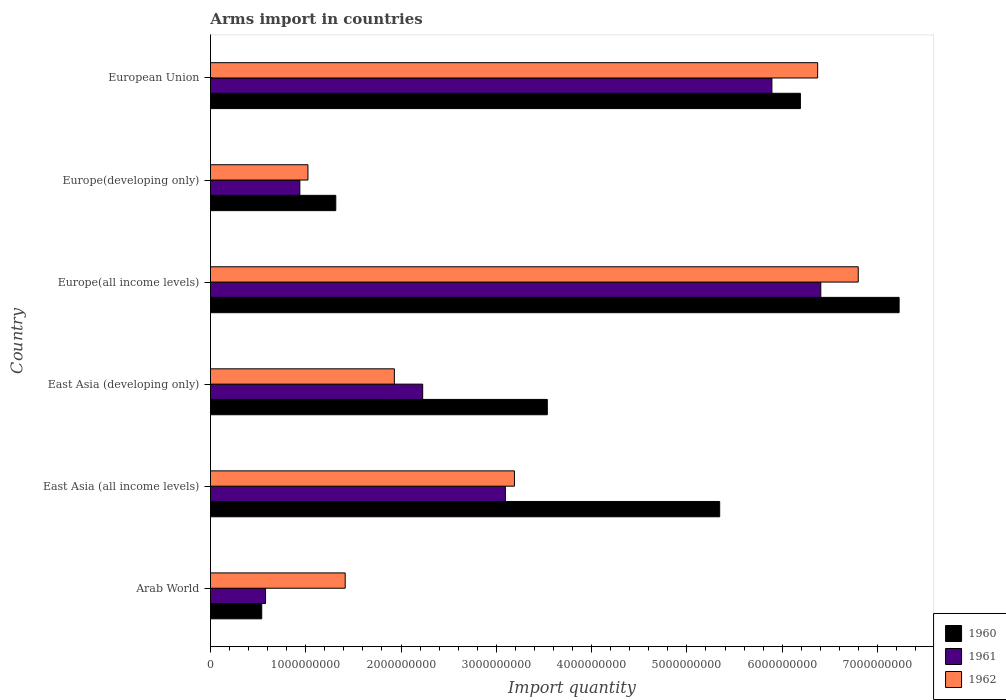How many groups of bars are there?
Provide a succinct answer. 6. Are the number of bars per tick equal to the number of legend labels?
Your answer should be very brief. Yes. Are the number of bars on each tick of the Y-axis equal?
Make the answer very short. Yes. How many bars are there on the 4th tick from the top?
Offer a very short reply. 3. How many bars are there on the 3rd tick from the bottom?
Give a very brief answer. 3. What is the label of the 2nd group of bars from the top?
Your response must be concise. Europe(developing only). What is the total arms import in 1961 in East Asia (all income levels)?
Give a very brief answer. 3.10e+09. Across all countries, what is the maximum total arms import in 1962?
Your answer should be compact. 6.80e+09. Across all countries, what is the minimum total arms import in 1961?
Your answer should be very brief. 5.78e+08. In which country was the total arms import in 1962 maximum?
Provide a short and direct response. Europe(all income levels). In which country was the total arms import in 1960 minimum?
Your answer should be very brief. Arab World. What is the total total arms import in 1962 in the graph?
Your answer should be very brief. 2.07e+1. What is the difference between the total arms import in 1961 in East Asia (developing only) and that in Europe(all income levels)?
Your answer should be very brief. -4.18e+09. What is the difference between the total arms import in 1960 in Europe(developing only) and the total arms import in 1961 in Arab World?
Keep it short and to the point. 7.37e+08. What is the average total arms import in 1962 per country?
Offer a terse response. 3.45e+09. What is the difference between the total arms import in 1960 and total arms import in 1961 in European Union?
Your answer should be very brief. 2.99e+08. What is the ratio of the total arms import in 1961 in Europe(all income levels) to that in Europe(developing only)?
Your answer should be very brief. 6.83. Is the total arms import in 1960 in Arab World less than that in East Asia (developing only)?
Your response must be concise. Yes. Is the difference between the total arms import in 1960 in East Asia (developing only) and European Union greater than the difference between the total arms import in 1961 in East Asia (developing only) and European Union?
Offer a terse response. Yes. What is the difference between the highest and the second highest total arms import in 1961?
Your answer should be compact. 5.13e+08. What is the difference between the highest and the lowest total arms import in 1961?
Offer a terse response. 5.83e+09. What does the 2nd bar from the top in Europe(all income levels) represents?
Provide a short and direct response. 1961. Is it the case that in every country, the sum of the total arms import in 1961 and total arms import in 1960 is greater than the total arms import in 1962?
Offer a terse response. No. How many bars are there?
Ensure brevity in your answer.  18. Are the values on the major ticks of X-axis written in scientific E-notation?
Provide a succinct answer. No. Does the graph contain any zero values?
Your answer should be very brief. No. Does the graph contain grids?
Offer a terse response. No. What is the title of the graph?
Ensure brevity in your answer.  Arms import in countries. Does "1973" appear as one of the legend labels in the graph?
Give a very brief answer. No. What is the label or title of the X-axis?
Your answer should be very brief. Import quantity. What is the Import quantity in 1960 in Arab World?
Your answer should be compact. 5.38e+08. What is the Import quantity in 1961 in Arab World?
Provide a succinct answer. 5.78e+08. What is the Import quantity of 1962 in Arab World?
Provide a short and direct response. 1.41e+09. What is the Import quantity of 1960 in East Asia (all income levels)?
Keep it short and to the point. 5.34e+09. What is the Import quantity in 1961 in East Asia (all income levels)?
Provide a short and direct response. 3.10e+09. What is the Import quantity of 1962 in East Asia (all income levels)?
Provide a succinct answer. 3.19e+09. What is the Import quantity in 1960 in East Asia (developing only)?
Offer a terse response. 3.54e+09. What is the Import quantity in 1961 in East Asia (developing only)?
Keep it short and to the point. 2.23e+09. What is the Import quantity of 1962 in East Asia (developing only)?
Your answer should be compact. 1.93e+09. What is the Import quantity of 1960 in Europe(all income levels)?
Your answer should be compact. 7.23e+09. What is the Import quantity in 1961 in Europe(all income levels)?
Provide a short and direct response. 6.40e+09. What is the Import quantity in 1962 in Europe(all income levels)?
Provide a succinct answer. 6.80e+09. What is the Import quantity in 1960 in Europe(developing only)?
Your answer should be very brief. 1.32e+09. What is the Import quantity in 1961 in Europe(developing only)?
Offer a terse response. 9.38e+08. What is the Import quantity of 1962 in Europe(developing only)?
Your response must be concise. 1.02e+09. What is the Import quantity of 1960 in European Union?
Your response must be concise. 6.19e+09. What is the Import quantity in 1961 in European Union?
Make the answer very short. 5.89e+09. What is the Import quantity of 1962 in European Union?
Your answer should be compact. 6.37e+09. Across all countries, what is the maximum Import quantity in 1960?
Give a very brief answer. 7.23e+09. Across all countries, what is the maximum Import quantity in 1961?
Keep it short and to the point. 6.40e+09. Across all countries, what is the maximum Import quantity in 1962?
Keep it short and to the point. 6.80e+09. Across all countries, what is the minimum Import quantity of 1960?
Provide a succinct answer. 5.38e+08. Across all countries, what is the minimum Import quantity in 1961?
Provide a succinct answer. 5.78e+08. Across all countries, what is the minimum Import quantity of 1962?
Offer a terse response. 1.02e+09. What is the total Import quantity of 1960 in the graph?
Give a very brief answer. 2.42e+1. What is the total Import quantity of 1961 in the graph?
Your answer should be very brief. 1.91e+1. What is the total Import quantity in 1962 in the graph?
Your answer should be very brief. 2.07e+1. What is the difference between the Import quantity in 1960 in Arab World and that in East Asia (all income levels)?
Provide a short and direct response. -4.81e+09. What is the difference between the Import quantity in 1961 in Arab World and that in East Asia (all income levels)?
Offer a terse response. -2.52e+09. What is the difference between the Import quantity of 1962 in Arab World and that in East Asia (all income levels)?
Provide a short and direct response. -1.78e+09. What is the difference between the Import quantity in 1960 in Arab World and that in East Asia (developing only)?
Your answer should be very brief. -3.00e+09. What is the difference between the Import quantity of 1961 in Arab World and that in East Asia (developing only)?
Your answer should be very brief. -1.65e+09. What is the difference between the Import quantity of 1962 in Arab World and that in East Asia (developing only)?
Ensure brevity in your answer.  -5.16e+08. What is the difference between the Import quantity in 1960 in Arab World and that in Europe(all income levels)?
Offer a terse response. -6.69e+09. What is the difference between the Import quantity of 1961 in Arab World and that in Europe(all income levels)?
Your answer should be compact. -5.83e+09. What is the difference between the Import quantity in 1962 in Arab World and that in Europe(all income levels)?
Your answer should be compact. -5.38e+09. What is the difference between the Import quantity of 1960 in Arab World and that in Europe(developing only)?
Provide a short and direct response. -7.77e+08. What is the difference between the Import quantity of 1961 in Arab World and that in Europe(developing only)?
Ensure brevity in your answer.  -3.60e+08. What is the difference between the Import quantity in 1962 in Arab World and that in Europe(developing only)?
Ensure brevity in your answer.  3.91e+08. What is the difference between the Import quantity of 1960 in Arab World and that in European Union?
Your response must be concise. -5.65e+09. What is the difference between the Import quantity of 1961 in Arab World and that in European Union?
Offer a very short reply. -5.31e+09. What is the difference between the Import quantity in 1962 in Arab World and that in European Union?
Your response must be concise. -4.96e+09. What is the difference between the Import quantity of 1960 in East Asia (all income levels) and that in East Asia (developing only)?
Offer a terse response. 1.81e+09. What is the difference between the Import quantity in 1961 in East Asia (all income levels) and that in East Asia (developing only)?
Give a very brief answer. 8.68e+08. What is the difference between the Import quantity in 1962 in East Asia (all income levels) and that in East Asia (developing only)?
Provide a short and direct response. 1.26e+09. What is the difference between the Import quantity in 1960 in East Asia (all income levels) and that in Europe(all income levels)?
Ensure brevity in your answer.  -1.88e+09. What is the difference between the Import quantity in 1961 in East Asia (all income levels) and that in Europe(all income levels)?
Give a very brief answer. -3.31e+09. What is the difference between the Import quantity in 1962 in East Asia (all income levels) and that in Europe(all income levels)?
Provide a short and direct response. -3.61e+09. What is the difference between the Import quantity in 1960 in East Asia (all income levels) and that in Europe(developing only)?
Ensure brevity in your answer.  4.03e+09. What is the difference between the Import quantity in 1961 in East Asia (all income levels) and that in Europe(developing only)?
Offer a very short reply. 2.16e+09. What is the difference between the Import quantity in 1962 in East Asia (all income levels) and that in Europe(developing only)?
Make the answer very short. 2.17e+09. What is the difference between the Import quantity of 1960 in East Asia (all income levels) and that in European Union?
Offer a terse response. -8.47e+08. What is the difference between the Import quantity of 1961 in East Asia (all income levels) and that in European Union?
Your answer should be compact. -2.80e+09. What is the difference between the Import quantity in 1962 in East Asia (all income levels) and that in European Union?
Your response must be concise. -3.18e+09. What is the difference between the Import quantity in 1960 in East Asia (developing only) and that in Europe(all income levels)?
Offer a very short reply. -3.69e+09. What is the difference between the Import quantity in 1961 in East Asia (developing only) and that in Europe(all income levels)?
Provide a short and direct response. -4.18e+09. What is the difference between the Import quantity in 1962 in East Asia (developing only) and that in Europe(all income levels)?
Your response must be concise. -4.87e+09. What is the difference between the Import quantity in 1960 in East Asia (developing only) and that in Europe(developing only)?
Provide a succinct answer. 2.22e+09. What is the difference between the Import quantity in 1961 in East Asia (developing only) and that in Europe(developing only)?
Offer a very short reply. 1.29e+09. What is the difference between the Import quantity of 1962 in East Asia (developing only) and that in Europe(developing only)?
Make the answer very short. 9.07e+08. What is the difference between the Import quantity in 1960 in East Asia (developing only) and that in European Union?
Keep it short and to the point. -2.66e+09. What is the difference between the Import quantity of 1961 in East Asia (developing only) and that in European Union?
Your response must be concise. -3.66e+09. What is the difference between the Import quantity of 1962 in East Asia (developing only) and that in European Union?
Give a very brief answer. -4.44e+09. What is the difference between the Import quantity in 1960 in Europe(all income levels) and that in Europe(developing only)?
Ensure brevity in your answer.  5.91e+09. What is the difference between the Import quantity of 1961 in Europe(all income levels) and that in Europe(developing only)?
Your answer should be very brief. 5.47e+09. What is the difference between the Import quantity of 1962 in Europe(all income levels) and that in Europe(developing only)?
Your answer should be very brief. 5.78e+09. What is the difference between the Import quantity of 1960 in Europe(all income levels) and that in European Union?
Ensure brevity in your answer.  1.04e+09. What is the difference between the Import quantity in 1961 in Europe(all income levels) and that in European Union?
Keep it short and to the point. 5.13e+08. What is the difference between the Import quantity in 1962 in Europe(all income levels) and that in European Union?
Provide a succinct answer. 4.26e+08. What is the difference between the Import quantity in 1960 in Europe(developing only) and that in European Union?
Your response must be concise. -4.88e+09. What is the difference between the Import quantity in 1961 in Europe(developing only) and that in European Union?
Your response must be concise. -4.95e+09. What is the difference between the Import quantity in 1962 in Europe(developing only) and that in European Union?
Ensure brevity in your answer.  -5.35e+09. What is the difference between the Import quantity in 1960 in Arab World and the Import quantity in 1961 in East Asia (all income levels)?
Keep it short and to the point. -2.56e+09. What is the difference between the Import quantity of 1960 in Arab World and the Import quantity of 1962 in East Asia (all income levels)?
Ensure brevity in your answer.  -2.65e+09. What is the difference between the Import quantity in 1961 in Arab World and the Import quantity in 1962 in East Asia (all income levels)?
Offer a very short reply. -2.61e+09. What is the difference between the Import quantity of 1960 in Arab World and the Import quantity of 1961 in East Asia (developing only)?
Your response must be concise. -1.69e+09. What is the difference between the Import quantity in 1960 in Arab World and the Import quantity in 1962 in East Asia (developing only)?
Keep it short and to the point. -1.39e+09. What is the difference between the Import quantity of 1961 in Arab World and the Import quantity of 1962 in East Asia (developing only)?
Ensure brevity in your answer.  -1.35e+09. What is the difference between the Import quantity of 1960 in Arab World and the Import quantity of 1961 in Europe(all income levels)?
Keep it short and to the point. -5.87e+09. What is the difference between the Import quantity in 1960 in Arab World and the Import quantity in 1962 in Europe(all income levels)?
Provide a succinct answer. -6.26e+09. What is the difference between the Import quantity of 1961 in Arab World and the Import quantity of 1962 in Europe(all income levels)?
Give a very brief answer. -6.22e+09. What is the difference between the Import quantity of 1960 in Arab World and the Import quantity of 1961 in Europe(developing only)?
Offer a terse response. -4.00e+08. What is the difference between the Import quantity of 1960 in Arab World and the Import quantity of 1962 in Europe(developing only)?
Keep it short and to the point. -4.85e+08. What is the difference between the Import quantity of 1961 in Arab World and the Import quantity of 1962 in Europe(developing only)?
Give a very brief answer. -4.45e+08. What is the difference between the Import quantity in 1960 in Arab World and the Import quantity in 1961 in European Union?
Your response must be concise. -5.35e+09. What is the difference between the Import quantity in 1960 in Arab World and the Import quantity in 1962 in European Union?
Offer a very short reply. -5.83e+09. What is the difference between the Import quantity in 1961 in Arab World and the Import quantity in 1962 in European Union?
Offer a very short reply. -5.79e+09. What is the difference between the Import quantity of 1960 in East Asia (all income levels) and the Import quantity of 1961 in East Asia (developing only)?
Provide a succinct answer. 3.12e+09. What is the difference between the Import quantity in 1960 in East Asia (all income levels) and the Import quantity in 1962 in East Asia (developing only)?
Give a very brief answer. 3.41e+09. What is the difference between the Import quantity of 1961 in East Asia (all income levels) and the Import quantity of 1962 in East Asia (developing only)?
Keep it short and to the point. 1.16e+09. What is the difference between the Import quantity of 1960 in East Asia (all income levels) and the Import quantity of 1961 in Europe(all income levels)?
Offer a very short reply. -1.06e+09. What is the difference between the Import quantity of 1960 in East Asia (all income levels) and the Import quantity of 1962 in Europe(all income levels)?
Give a very brief answer. -1.45e+09. What is the difference between the Import quantity of 1961 in East Asia (all income levels) and the Import quantity of 1962 in Europe(all income levels)?
Offer a terse response. -3.70e+09. What is the difference between the Import quantity of 1960 in East Asia (all income levels) and the Import quantity of 1961 in Europe(developing only)?
Offer a very short reply. 4.41e+09. What is the difference between the Import quantity in 1960 in East Asia (all income levels) and the Import quantity in 1962 in Europe(developing only)?
Your answer should be compact. 4.32e+09. What is the difference between the Import quantity in 1961 in East Asia (all income levels) and the Import quantity in 1962 in Europe(developing only)?
Keep it short and to the point. 2.07e+09. What is the difference between the Import quantity of 1960 in East Asia (all income levels) and the Import quantity of 1961 in European Union?
Your answer should be very brief. -5.48e+08. What is the difference between the Import quantity in 1960 in East Asia (all income levels) and the Import quantity in 1962 in European Union?
Offer a very short reply. -1.03e+09. What is the difference between the Import quantity of 1961 in East Asia (all income levels) and the Import quantity of 1962 in European Union?
Ensure brevity in your answer.  -3.28e+09. What is the difference between the Import quantity in 1960 in East Asia (developing only) and the Import quantity in 1961 in Europe(all income levels)?
Provide a short and direct response. -2.87e+09. What is the difference between the Import quantity in 1960 in East Asia (developing only) and the Import quantity in 1962 in Europe(all income levels)?
Your answer should be very brief. -3.26e+09. What is the difference between the Import quantity of 1961 in East Asia (developing only) and the Import quantity of 1962 in Europe(all income levels)?
Provide a succinct answer. -4.57e+09. What is the difference between the Import quantity in 1960 in East Asia (developing only) and the Import quantity in 1961 in Europe(developing only)?
Offer a very short reply. 2.60e+09. What is the difference between the Import quantity in 1960 in East Asia (developing only) and the Import quantity in 1962 in Europe(developing only)?
Keep it short and to the point. 2.51e+09. What is the difference between the Import quantity of 1961 in East Asia (developing only) and the Import quantity of 1962 in Europe(developing only)?
Ensure brevity in your answer.  1.20e+09. What is the difference between the Import quantity in 1960 in East Asia (developing only) and the Import quantity in 1961 in European Union?
Provide a succinct answer. -2.36e+09. What is the difference between the Import quantity in 1960 in East Asia (developing only) and the Import quantity in 1962 in European Union?
Your response must be concise. -2.84e+09. What is the difference between the Import quantity of 1961 in East Asia (developing only) and the Import quantity of 1962 in European Union?
Make the answer very short. -4.14e+09. What is the difference between the Import quantity of 1960 in Europe(all income levels) and the Import quantity of 1961 in Europe(developing only)?
Provide a short and direct response. 6.29e+09. What is the difference between the Import quantity in 1960 in Europe(all income levels) and the Import quantity in 1962 in Europe(developing only)?
Offer a terse response. 6.20e+09. What is the difference between the Import quantity in 1961 in Europe(all income levels) and the Import quantity in 1962 in Europe(developing only)?
Ensure brevity in your answer.  5.38e+09. What is the difference between the Import quantity of 1960 in Europe(all income levels) and the Import quantity of 1961 in European Union?
Offer a very short reply. 1.34e+09. What is the difference between the Import quantity of 1960 in Europe(all income levels) and the Import quantity of 1962 in European Union?
Make the answer very short. 8.55e+08. What is the difference between the Import quantity of 1961 in Europe(all income levels) and the Import quantity of 1962 in European Union?
Your response must be concise. 3.30e+07. What is the difference between the Import quantity of 1960 in Europe(developing only) and the Import quantity of 1961 in European Union?
Provide a short and direct response. -4.58e+09. What is the difference between the Import quantity of 1960 in Europe(developing only) and the Import quantity of 1962 in European Union?
Make the answer very short. -5.06e+09. What is the difference between the Import quantity of 1961 in Europe(developing only) and the Import quantity of 1962 in European Union?
Your response must be concise. -5.43e+09. What is the average Import quantity of 1960 per country?
Provide a short and direct response. 4.02e+09. What is the average Import quantity in 1961 per country?
Offer a very short reply. 3.19e+09. What is the average Import quantity of 1962 per country?
Make the answer very short. 3.45e+09. What is the difference between the Import quantity in 1960 and Import quantity in 1961 in Arab World?
Keep it short and to the point. -4.00e+07. What is the difference between the Import quantity of 1960 and Import quantity of 1962 in Arab World?
Offer a very short reply. -8.76e+08. What is the difference between the Import quantity of 1961 and Import quantity of 1962 in Arab World?
Ensure brevity in your answer.  -8.36e+08. What is the difference between the Import quantity of 1960 and Import quantity of 1961 in East Asia (all income levels)?
Make the answer very short. 2.25e+09. What is the difference between the Import quantity of 1960 and Import quantity of 1962 in East Asia (all income levels)?
Provide a short and direct response. 2.15e+09. What is the difference between the Import quantity of 1961 and Import quantity of 1962 in East Asia (all income levels)?
Provide a short and direct response. -9.50e+07. What is the difference between the Import quantity in 1960 and Import quantity in 1961 in East Asia (developing only)?
Your answer should be very brief. 1.31e+09. What is the difference between the Import quantity in 1960 and Import quantity in 1962 in East Asia (developing only)?
Your answer should be compact. 1.60e+09. What is the difference between the Import quantity in 1961 and Import quantity in 1962 in East Asia (developing only)?
Provide a short and direct response. 2.97e+08. What is the difference between the Import quantity in 1960 and Import quantity in 1961 in Europe(all income levels)?
Provide a short and direct response. 8.22e+08. What is the difference between the Import quantity of 1960 and Import quantity of 1962 in Europe(all income levels)?
Your answer should be compact. 4.29e+08. What is the difference between the Import quantity in 1961 and Import quantity in 1962 in Europe(all income levels)?
Offer a very short reply. -3.93e+08. What is the difference between the Import quantity in 1960 and Import quantity in 1961 in Europe(developing only)?
Make the answer very short. 3.77e+08. What is the difference between the Import quantity in 1960 and Import quantity in 1962 in Europe(developing only)?
Offer a terse response. 2.92e+08. What is the difference between the Import quantity of 1961 and Import quantity of 1962 in Europe(developing only)?
Provide a succinct answer. -8.50e+07. What is the difference between the Import quantity in 1960 and Import quantity in 1961 in European Union?
Keep it short and to the point. 2.99e+08. What is the difference between the Import quantity in 1960 and Import quantity in 1962 in European Union?
Provide a short and direct response. -1.81e+08. What is the difference between the Import quantity of 1961 and Import quantity of 1962 in European Union?
Provide a succinct answer. -4.80e+08. What is the ratio of the Import quantity of 1960 in Arab World to that in East Asia (all income levels)?
Your response must be concise. 0.1. What is the ratio of the Import quantity in 1961 in Arab World to that in East Asia (all income levels)?
Give a very brief answer. 0.19. What is the ratio of the Import quantity in 1962 in Arab World to that in East Asia (all income levels)?
Your response must be concise. 0.44. What is the ratio of the Import quantity in 1960 in Arab World to that in East Asia (developing only)?
Give a very brief answer. 0.15. What is the ratio of the Import quantity of 1961 in Arab World to that in East Asia (developing only)?
Provide a short and direct response. 0.26. What is the ratio of the Import quantity of 1962 in Arab World to that in East Asia (developing only)?
Offer a terse response. 0.73. What is the ratio of the Import quantity in 1960 in Arab World to that in Europe(all income levels)?
Ensure brevity in your answer.  0.07. What is the ratio of the Import quantity in 1961 in Arab World to that in Europe(all income levels)?
Provide a short and direct response. 0.09. What is the ratio of the Import quantity of 1962 in Arab World to that in Europe(all income levels)?
Your answer should be very brief. 0.21. What is the ratio of the Import quantity of 1960 in Arab World to that in Europe(developing only)?
Make the answer very short. 0.41. What is the ratio of the Import quantity in 1961 in Arab World to that in Europe(developing only)?
Provide a short and direct response. 0.62. What is the ratio of the Import quantity of 1962 in Arab World to that in Europe(developing only)?
Keep it short and to the point. 1.38. What is the ratio of the Import quantity of 1960 in Arab World to that in European Union?
Keep it short and to the point. 0.09. What is the ratio of the Import quantity in 1961 in Arab World to that in European Union?
Provide a short and direct response. 0.1. What is the ratio of the Import quantity in 1962 in Arab World to that in European Union?
Offer a very short reply. 0.22. What is the ratio of the Import quantity of 1960 in East Asia (all income levels) to that in East Asia (developing only)?
Your answer should be compact. 1.51. What is the ratio of the Import quantity of 1961 in East Asia (all income levels) to that in East Asia (developing only)?
Provide a succinct answer. 1.39. What is the ratio of the Import quantity in 1962 in East Asia (all income levels) to that in East Asia (developing only)?
Offer a very short reply. 1.65. What is the ratio of the Import quantity in 1960 in East Asia (all income levels) to that in Europe(all income levels)?
Make the answer very short. 0.74. What is the ratio of the Import quantity in 1961 in East Asia (all income levels) to that in Europe(all income levels)?
Offer a very short reply. 0.48. What is the ratio of the Import quantity of 1962 in East Asia (all income levels) to that in Europe(all income levels)?
Keep it short and to the point. 0.47. What is the ratio of the Import quantity of 1960 in East Asia (all income levels) to that in Europe(developing only)?
Ensure brevity in your answer.  4.06. What is the ratio of the Import quantity of 1961 in East Asia (all income levels) to that in Europe(developing only)?
Your answer should be very brief. 3.3. What is the ratio of the Import quantity in 1962 in East Asia (all income levels) to that in Europe(developing only)?
Your response must be concise. 3.12. What is the ratio of the Import quantity of 1960 in East Asia (all income levels) to that in European Union?
Offer a very short reply. 0.86. What is the ratio of the Import quantity in 1961 in East Asia (all income levels) to that in European Union?
Make the answer very short. 0.53. What is the ratio of the Import quantity in 1962 in East Asia (all income levels) to that in European Union?
Give a very brief answer. 0.5. What is the ratio of the Import quantity of 1960 in East Asia (developing only) to that in Europe(all income levels)?
Give a very brief answer. 0.49. What is the ratio of the Import quantity in 1961 in East Asia (developing only) to that in Europe(all income levels)?
Give a very brief answer. 0.35. What is the ratio of the Import quantity of 1962 in East Asia (developing only) to that in Europe(all income levels)?
Offer a terse response. 0.28. What is the ratio of the Import quantity of 1960 in East Asia (developing only) to that in Europe(developing only)?
Provide a short and direct response. 2.69. What is the ratio of the Import quantity in 1961 in East Asia (developing only) to that in Europe(developing only)?
Make the answer very short. 2.37. What is the ratio of the Import quantity in 1962 in East Asia (developing only) to that in Europe(developing only)?
Ensure brevity in your answer.  1.89. What is the ratio of the Import quantity of 1960 in East Asia (developing only) to that in European Union?
Make the answer very short. 0.57. What is the ratio of the Import quantity in 1961 in East Asia (developing only) to that in European Union?
Your answer should be compact. 0.38. What is the ratio of the Import quantity in 1962 in East Asia (developing only) to that in European Union?
Provide a short and direct response. 0.3. What is the ratio of the Import quantity of 1960 in Europe(all income levels) to that in Europe(developing only)?
Your answer should be compact. 5.5. What is the ratio of the Import quantity of 1961 in Europe(all income levels) to that in Europe(developing only)?
Ensure brevity in your answer.  6.83. What is the ratio of the Import quantity of 1962 in Europe(all income levels) to that in Europe(developing only)?
Provide a succinct answer. 6.65. What is the ratio of the Import quantity of 1960 in Europe(all income levels) to that in European Union?
Offer a very short reply. 1.17. What is the ratio of the Import quantity in 1961 in Europe(all income levels) to that in European Union?
Offer a terse response. 1.09. What is the ratio of the Import quantity in 1962 in Europe(all income levels) to that in European Union?
Your response must be concise. 1.07. What is the ratio of the Import quantity in 1960 in Europe(developing only) to that in European Union?
Provide a succinct answer. 0.21. What is the ratio of the Import quantity in 1961 in Europe(developing only) to that in European Union?
Give a very brief answer. 0.16. What is the ratio of the Import quantity in 1962 in Europe(developing only) to that in European Union?
Your response must be concise. 0.16. What is the difference between the highest and the second highest Import quantity of 1960?
Your answer should be very brief. 1.04e+09. What is the difference between the highest and the second highest Import quantity of 1961?
Your response must be concise. 5.13e+08. What is the difference between the highest and the second highest Import quantity in 1962?
Offer a very short reply. 4.26e+08. What is the difference between the highest and the lowest Import quantity of 1960?
Offer a very short reply. 6.69e+09. What is the difference between the highest and the lowest Import quantity in 1961?
Offer a very short reply. 5.83e+09. What is the difference between the highest and the lowest Import quantity of 1962?
Offer a terse response. 5.78e+09. 